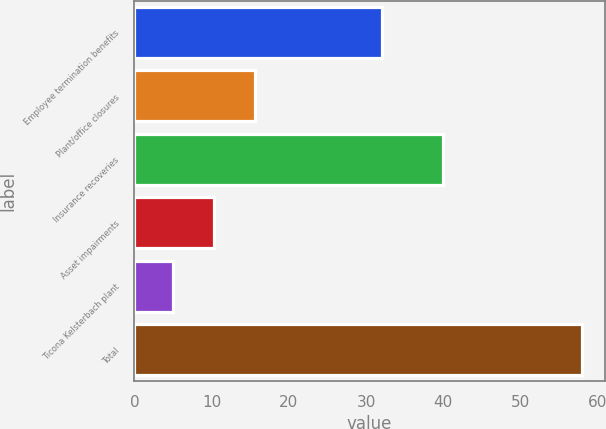Convert chart to OTSL. <chart><loc_0><loc_0><loc_500><loc_500><bar_chart><fcel>Employee termination benefits<fcel>Plant/office closures<fcel>Insurance recoveries<fcel>Asset impairments<fcel>Ticona Kelsterbach plant<fcel>Total<nl><fcel>32<fcel>15.6<fcel>40<fcel>10.3<fcel>5<fcel>58<nl></chart> 